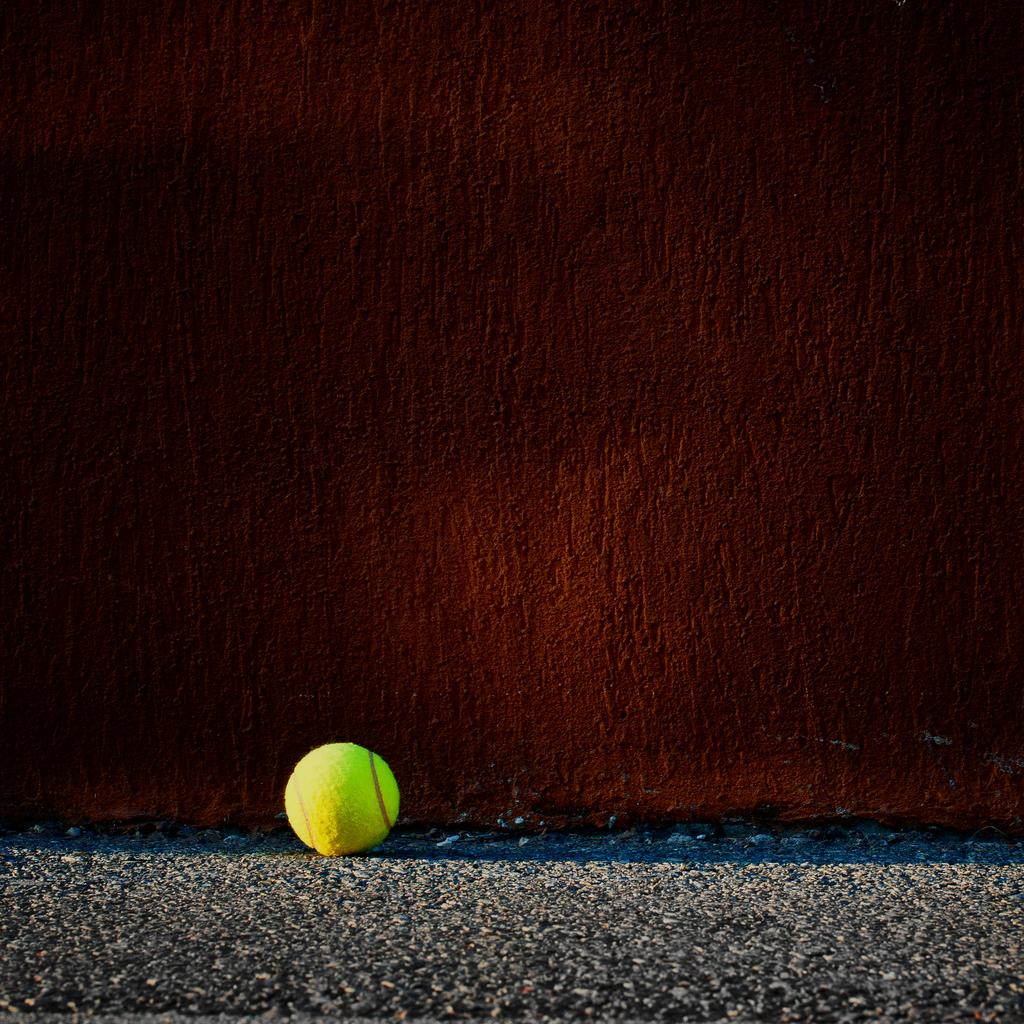What type of surface is visible in the image? There is a road surface in the image. What color and type of object can be seen on the road surface? There is a green color tennis ball on the road surface. What color and material is the wall visible in the image? There is a brown color wall in the image. What type of cloth is used to cover the bell in the image? There is no bell or cloth present in the image. 